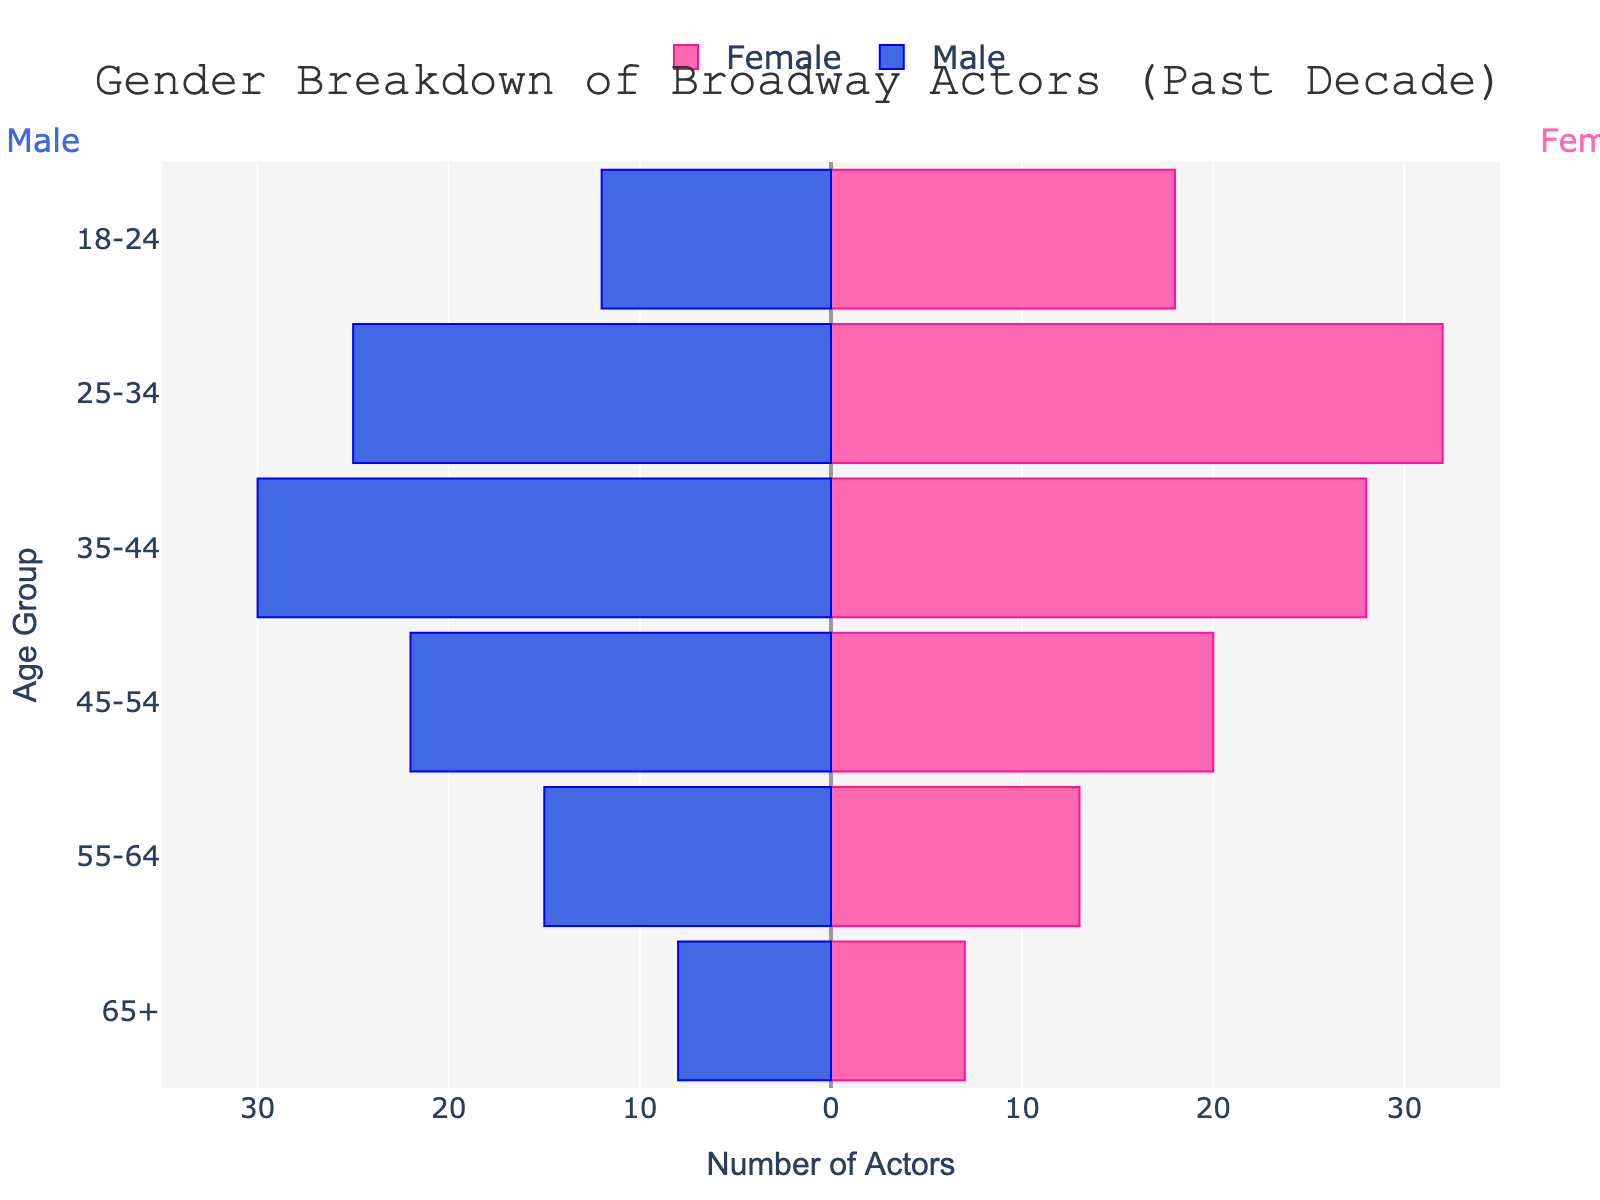what is the age group with the highest number of female actors? The age group with the highest number of female actors can be identified by looking at the longest pink bar for the female section. That group is 25-34 with 32 female actors.
Answer: 25-34 which age group has a higher number of actors for females than males? For each age group, compare the lengths of the bars for female and male sections. The age groups where the pink bar (female) is longer than the blue bar (male) are 18-24 and 25-34.
Answer: 18-24 and 25-34 what is the total number of male actors in the 35-44 and 45-54 age groups? Sum the number of male actors in the 35-44 and 45-54 age groups. The numbers are 30 and 22, respectively. Therefore, the total is 30 + 22 = 52.
Answer: 52 how many more female actors are there in the 18-24 age group compared to males? Subtract the number of male actors from the number of female actors in the 18-24 age group. The numbers are 18 (female) and 12 (male), so the difference is 18 - 12 = 6.
Answer: 6 what is the distribution of actors aged 55 and above by gender? Add the numbers of male and female actors for the age groups 55-64 and 65+. For males: 15 (55-64) + 8 (65+) = 23. For females: 13 (55-64) + 7 (65+) = 20. Therefore, the distribution for 55 and above is 23 males and 20 females.
Answer: 23 males and 20 females how does the number of actors aged 45-54 compare to those aged 65+ for both genders? Look at the lengths of the bars for the age groups 45-54 and 65+. Men: 22 (45-54) vs. 8 (65+). Women: 20 (45-54) vs. 7 (65+). For both genders, there are more actors in the 45-54 age group than in the 65+ age group.
Answer: More in 45-54 what proportion of the total actors in the 25-34 age group are female? To find the proportion, divide the number of female actors by the total number of actors in the 25-34 age group. The numbers are 32 (female) and 25 (male), so the total is 32 + 25 = 57. The proportion is 32 / 57.
Answer: 32/57 in which age group do male and female actors have the smallest difference in numbers? Calculate the difference in numbers for each age group and find the smallest difference. The differences are: 18-24: 6, 25-34: 7, 35-44: 2, 45-54: 2, 55-64: 2, 65+: 1. Therefore, the smallest difference is in the 65+ age group with a difference of 1 actor.
Answer: 65+ what is the average number of female actors across all age groups? Add up the number of female actors in each age group and divide by the number of age groups. The numbers are 18, 32, 28, 20, 13, 7. The sum is 18 + 32 + 28 + 20 + 13 + 7 = 118. The number of age groups is 6. The average is 118 / 6 = 19.67.
Answer: 19.67 